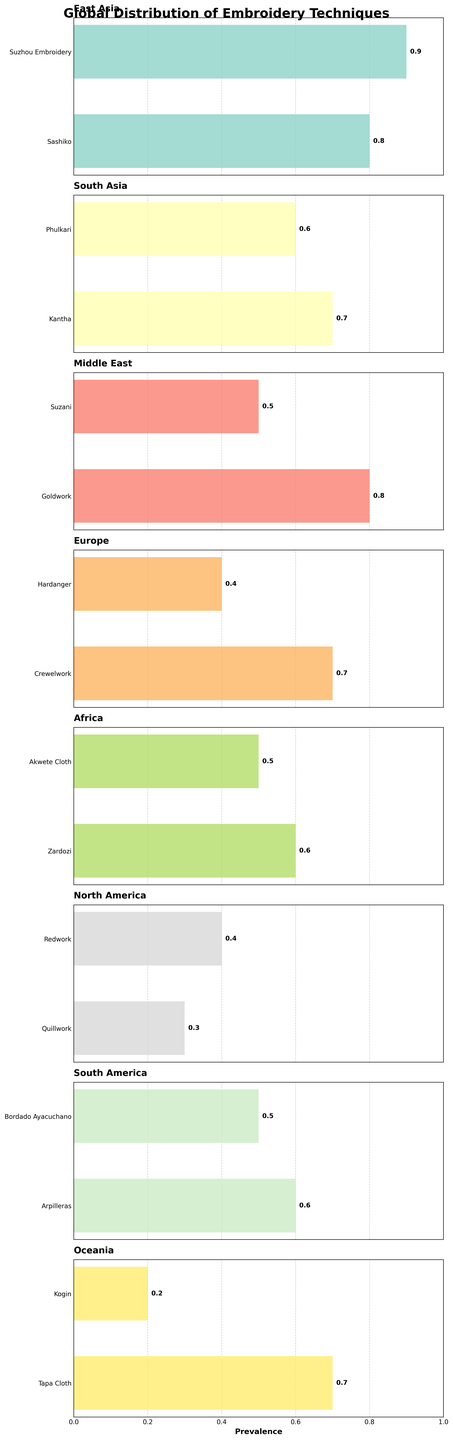What's the highest prevalence value in East Asia? The East Asia subplot has two techniques: Sashiko and Suzhou Embroidery, with prevalence values of 0.8 and 0.9, respectively. The highest value is 0.9.
Answer: 0.9 Which region has the technique with the lowest prevalence value? Comparing all subplots, the lowest prevalence value is 0.2 for Kogin in Oceania.
Answer: Oceania How many techniques in South Asia have a prevalence of 0.5 or higher? South Asia has two techniques: Kantha with 0.7 and Phulkari with 0.6. Both are 0.5 or higher. So, there are 2 techniques.
Answer: 2 What's the combined prevalence of Suzhou Embroidery and Sashiko in East Asia? In East Asia, Suzhou Embroidery has a prevalence of 0.9 and Sashiko has 0.8. Summing them up: 0.9 + 0.8 = 1.7.
Answer: 1.7 Which techniques in the Middle East have a higher prevalence than Suzani? Suzani in the Middle East has a prevalence of 0.5. Goldwork has a prevalence of 0.8, which is higher.
Answer: Goldwork What's the difference in prevalence between Kantha and Phulkari in South Asia? Kantha has a prevalence of 0.7, and Phulkari has 0.6. The difference is 0.7 - 0.6 = 0.1.
Answer: 0.1 How many regions have at least one technique with a prevalence of 0.7 or higher? Identify regions with techniques of 0.7 or more: East Asia (2), South Asia (1), Europe (1), South America (1), Oceania (1). This sums to 5 regions.
Answer: 5 What's the average prevalence of the techniques in Africa? Africa has two techniques: Zardozi with 0.6 and Akwete Cloth with 0.5. The average is (0.6 + 0.5)/2 = 0.55.
Answer: 0.55 